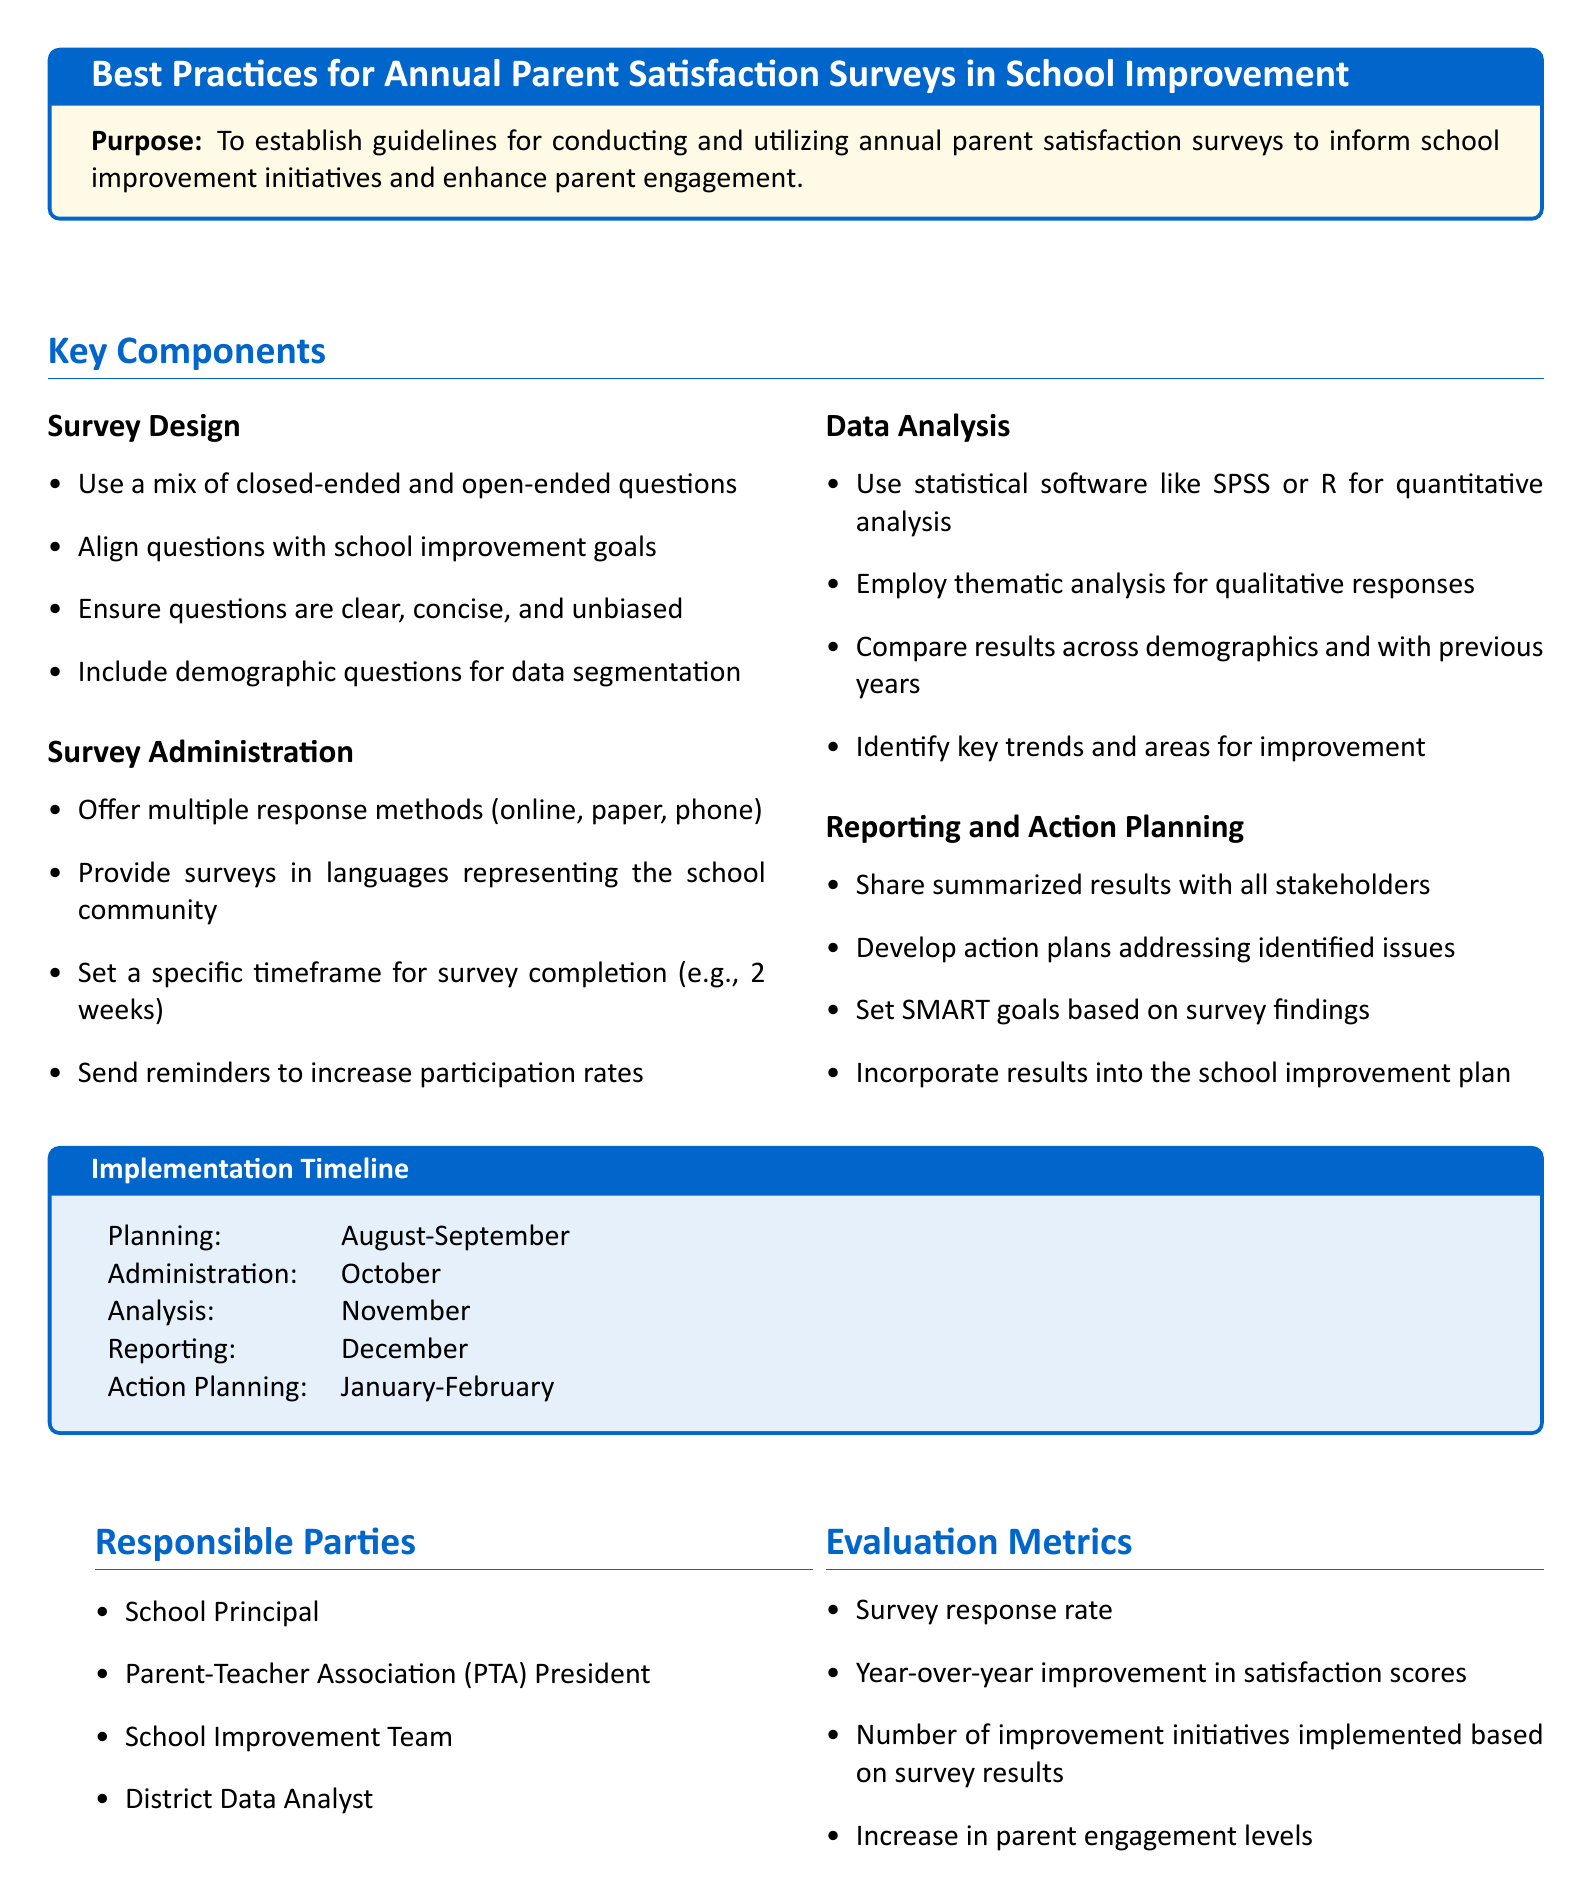What is the purpose of the document? The purpose is to establish guidelines for conducting and utilizing annual parent satisfaction surveys to inform school improvement initiatives and enhance parent engagement.
Answer: To establish guidelines for conducting and utilizing annual parent satisfaction surveys What month does the survey administration take place? The timeline specifies when the survey administration occurs, which is in October.
Answer: October Who is responsible for the action planning phase? The document lists the timeline and indicates the responsible parties for action planning. The parties listed include the School Improvement Team.
Answer: School Improvement Team What is the intended survey response rate metric? The document states that the survey response rate is one of the evaluation metrics to measure success.
Answer: Survey response rate In which month does survey analysis occur? The implementation timeline indicates that analysis happens in November.
Answer: November What type of analysis is recommended for qualitative responses? The best practice guidance on data analysis includes employing thematic analysis for qualitative responses.
Answer: Thematic analysis What do the survey questions need to align with? The survey design section indicates that questions should align with school improvement goals.
Answer: School improvement goals Which individuals are mentioned as responsible parties in the document? The responsible parties are the School Principal, PTA President, School Improvement Team, and District Data Analyst.
Answer: School Principal, PTA President, School Improvement Team, District Data Analyst What is the last phase of the implementation timeline? The document outlines the implementation phases, with action planning occurring in January-February.
Answer: January-February 